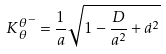<formula> <loc_0><loc_0><loc_500><loc_500>K { _ { \theta } ^ { \theta } } ^ { - } = \frac { 1 } { a } \sqrt { 1 - \frac { D } { a ^ { 2 } } + \dot { a } ^ { 2 } }</formula> 